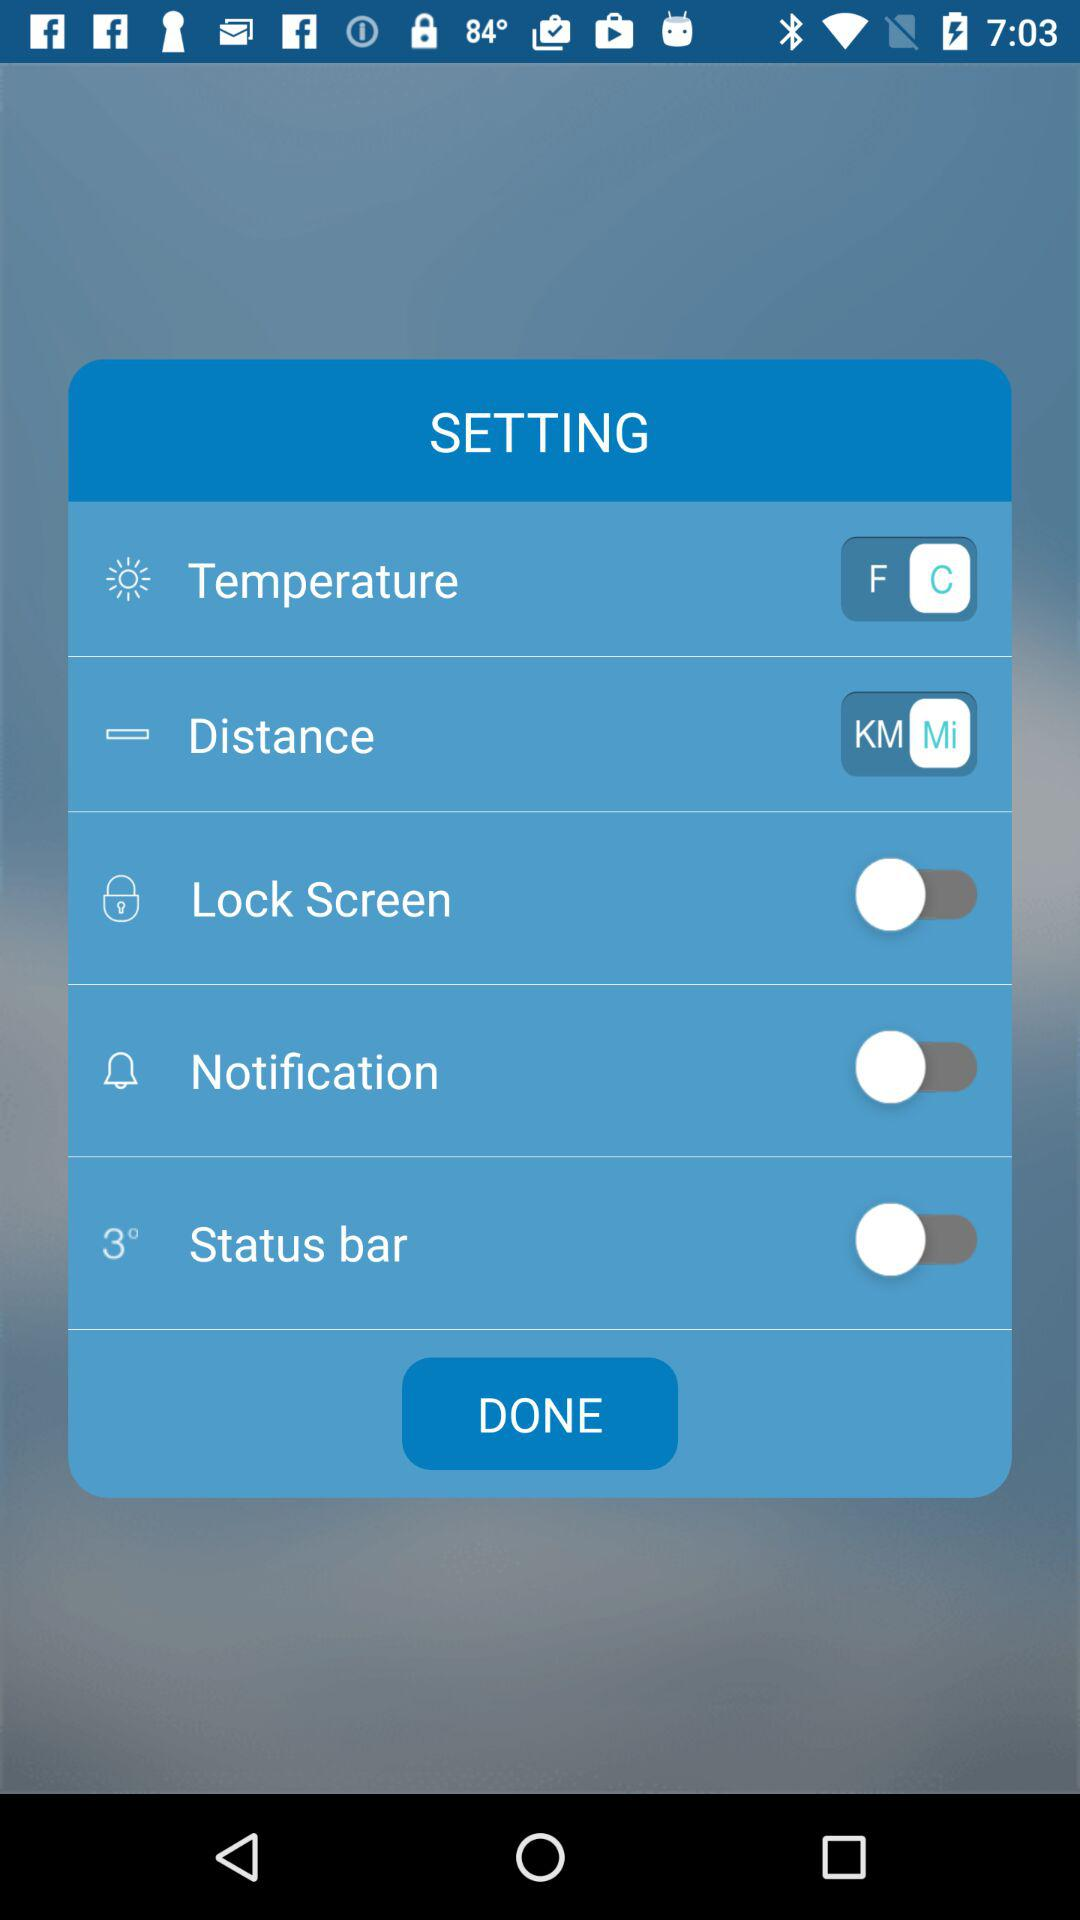What is the selected unit of temperature? The selected unit of temperature is C. 